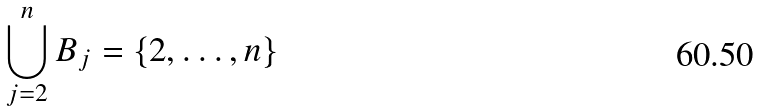Convert formula to latex. <formula><loc_0><loc_0><loc_500><loc_500>\bigcup _ { j = 2 } ^ { n } B _ { j } = \left \{ 2 , \dots , n \right \}</formula> 